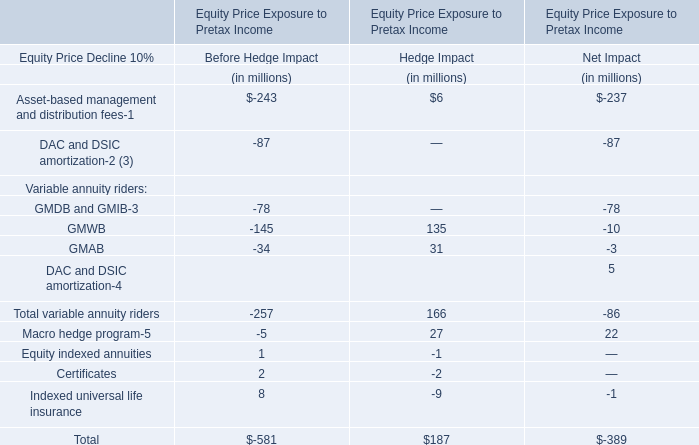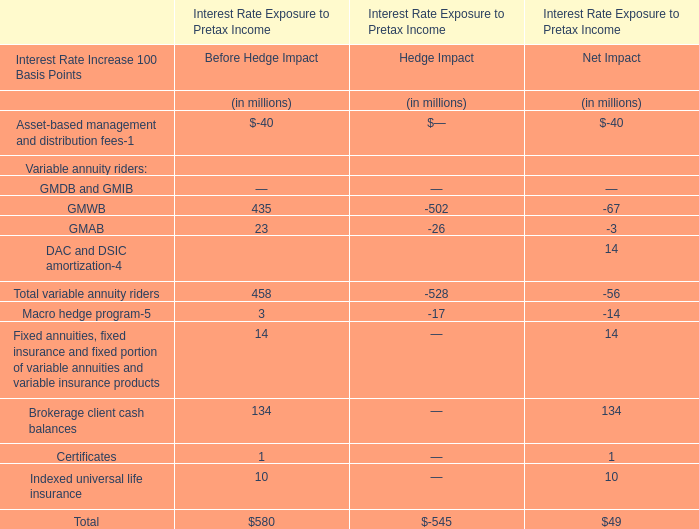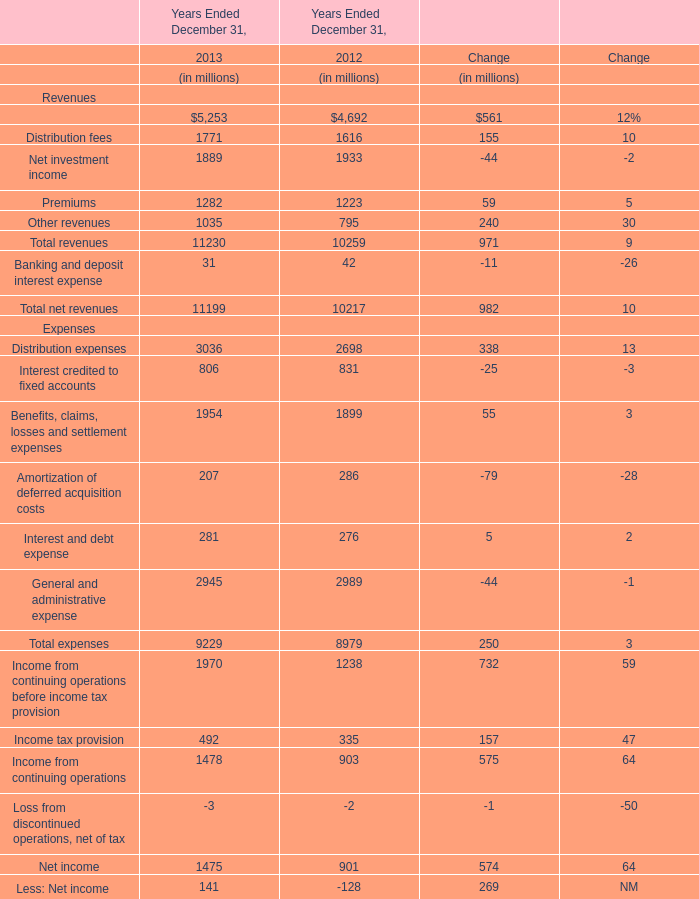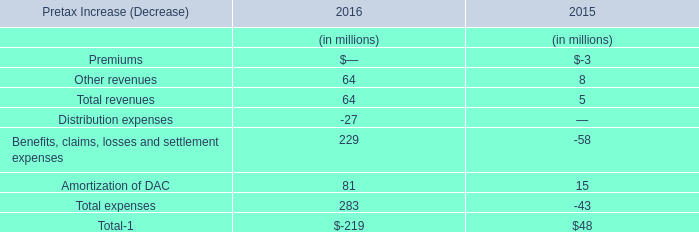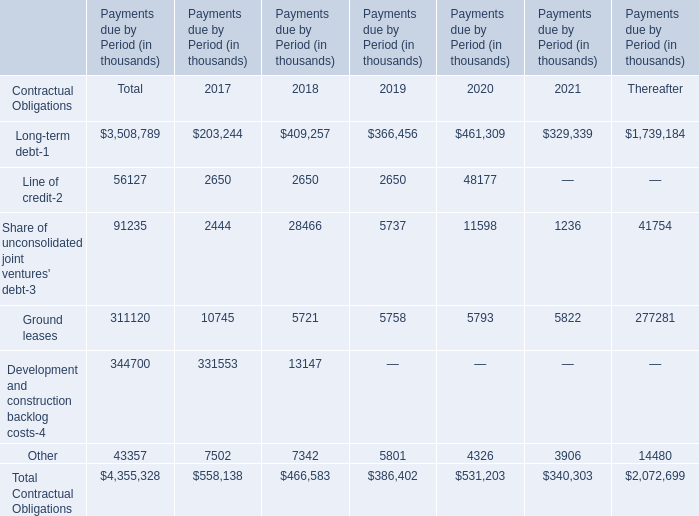What's the average of total revenues in 2013? (in $ in millions) 
Computations: (11230 / 5)
Answer: 2246.0. 